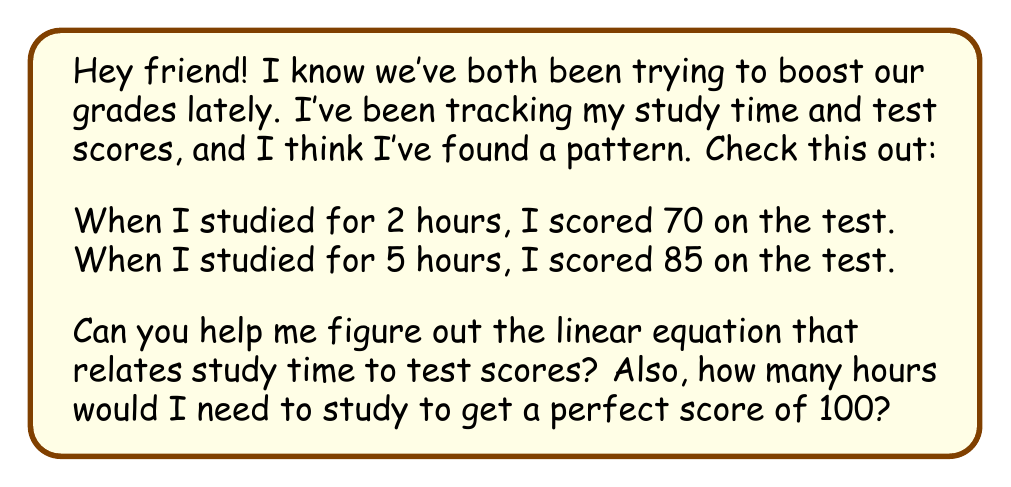Teach me how to tackle this problem. Sure thing! Let's break this down step-by-step:

1) First, we need to find the slope of the line. The slope represents how much the test score increases for each additional hour of studying.

   Slope = $\frac{\text{change in y}}{\text{change in x}} = \frac{\text{change in score}}{\text{change in study time}}$
   
   $$ m = \frac{85 - 70}{5 - 2} = \frac{15}{3} = 5 $$

   So, for each hour of studying, the test score increases by 5 points.

2) Now we can use the point-slope form of a line to create our equation:
   $y - y_1 = m(x - x_1)$

   Let's use the point (2, 70):
   $y - 70 = 5(x - 2)$

3) Simplify this equation:
   $y - 70 = 5x - 10$
   $y = 5x - 10 + 70$
   $y = 5x + 60$

   So our linear equation is $y = 5x + 60$, where $y$ is the test score and $x$ is the number of study hours.

4) To find how many hours are needed for a perfect score (100), we substitute $y = 100$:

   $100 = 5x + 60$
   $40 = 5x$
   $x = 8$

Therefore, you would need to study for 8 hours to get a perfect score of 100.
Answer: The linear equation relating study time to test scores is $y = 5x + 60$, where $y$ is the test score and $x$ is the number of study hours. To get a perfect score of 100, you would need to study for 8 hours. 